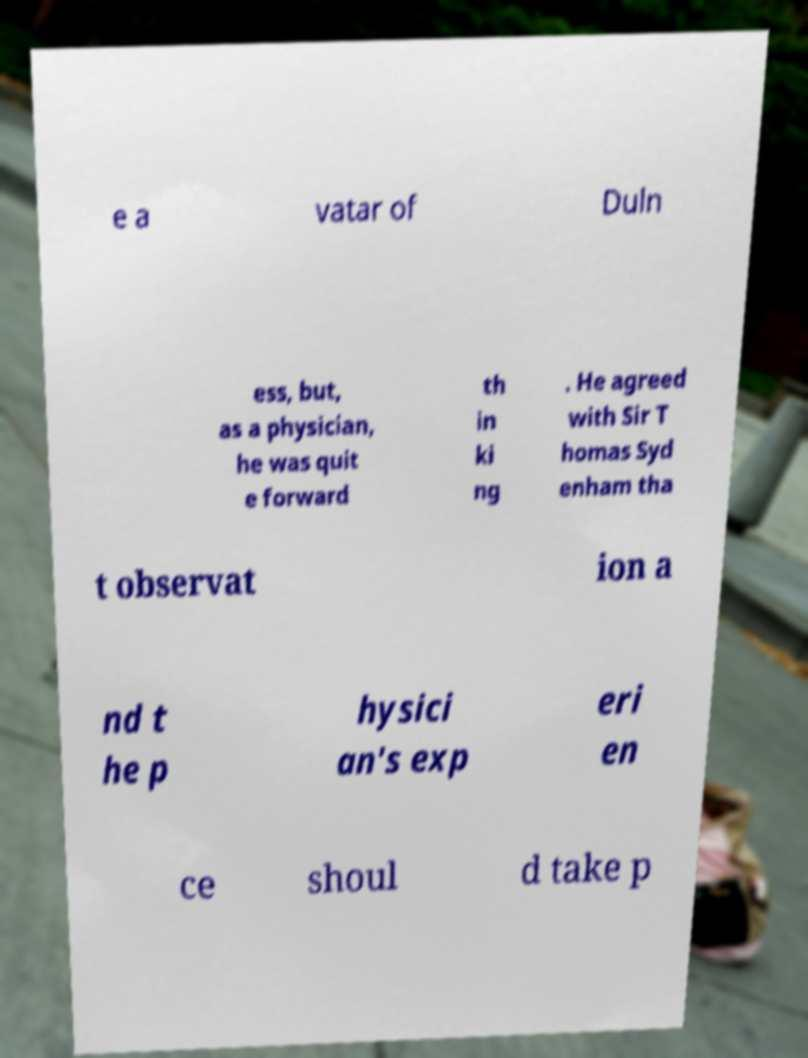Please read and relay the text visible in this image. What does it say? e a vatar of Duln ess, but, as a physician, he was quit e forward th in ki ng . He agreed with Sir T homas Syd enham tha t observat ion a nd t he p hysici an's exp eri en ce shoul d take p 